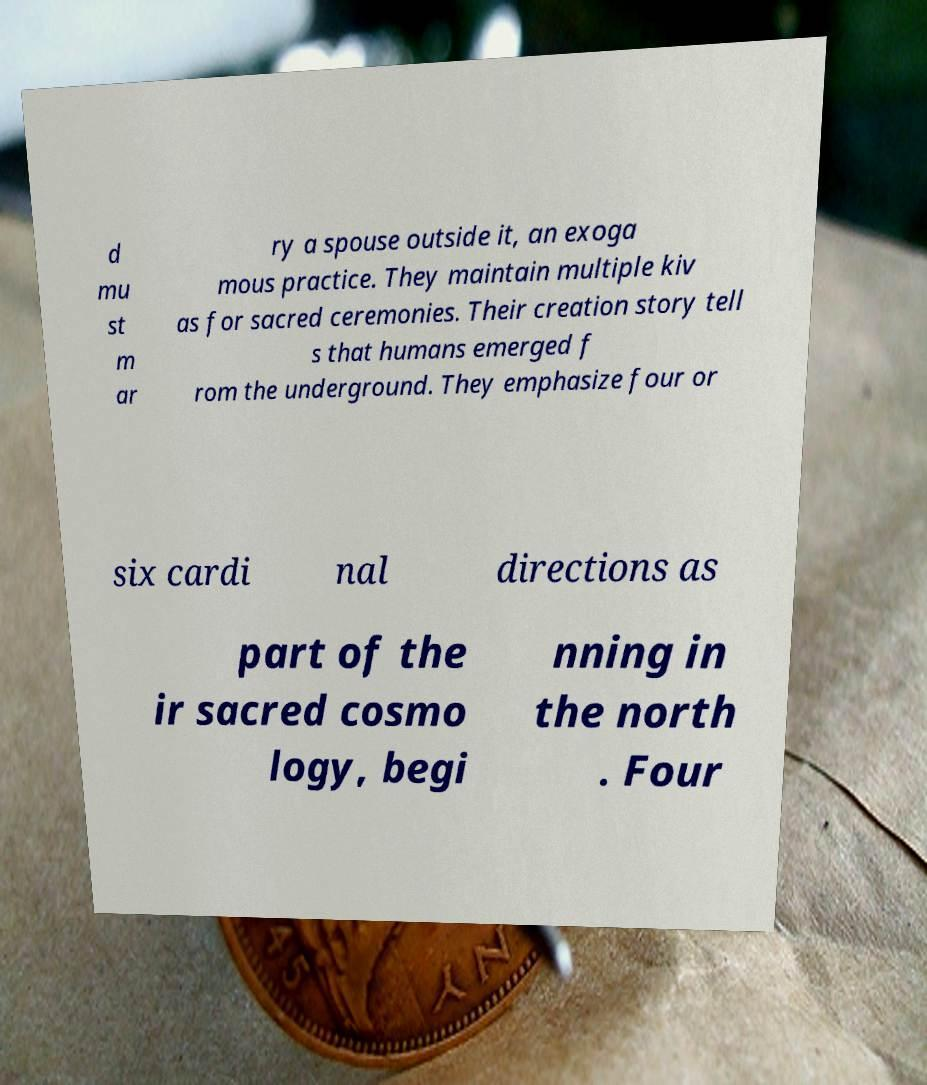Can you read and provide the text displayed in the image?This photo seems to have some interesting text. Can you extract and type it out for me? d mu st m ar ry a spouse outside it, an exoga mous practice. They maintain multiple kiv as for sacred ceremonies. Their creation story tell s that humans emerged f rom the underground. They emphasize four or six cardi nal directions as part of the ir sacred cosmo logy, begi nning in the north . Four 